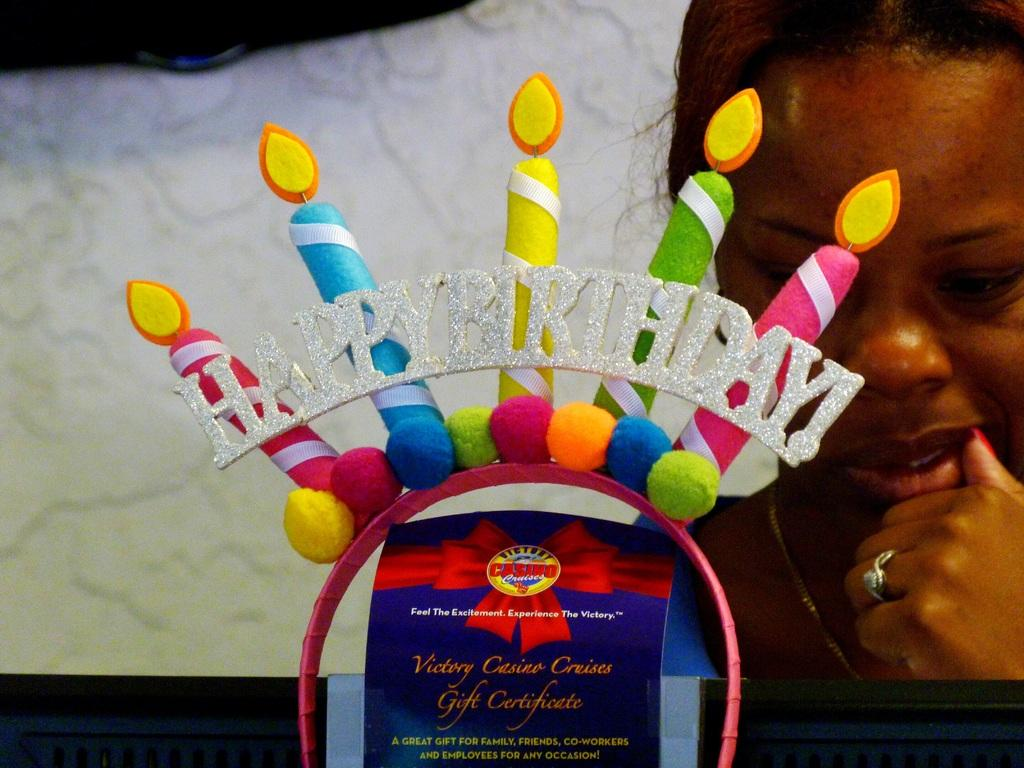What is the main object in the image? There is a colorful gift in the image. Can you describe the appearance of the gift? The gift is colorful, but the specific colors or design cannot be determined from the provided facts. Is there anyone else in the image besides the gift? Yes, there is a woman in the background of the image. What type of transport is being used to deliver the gift in the image? There is no transport visible in the image, and the method of delivery is not mentioned in the provided facts. 